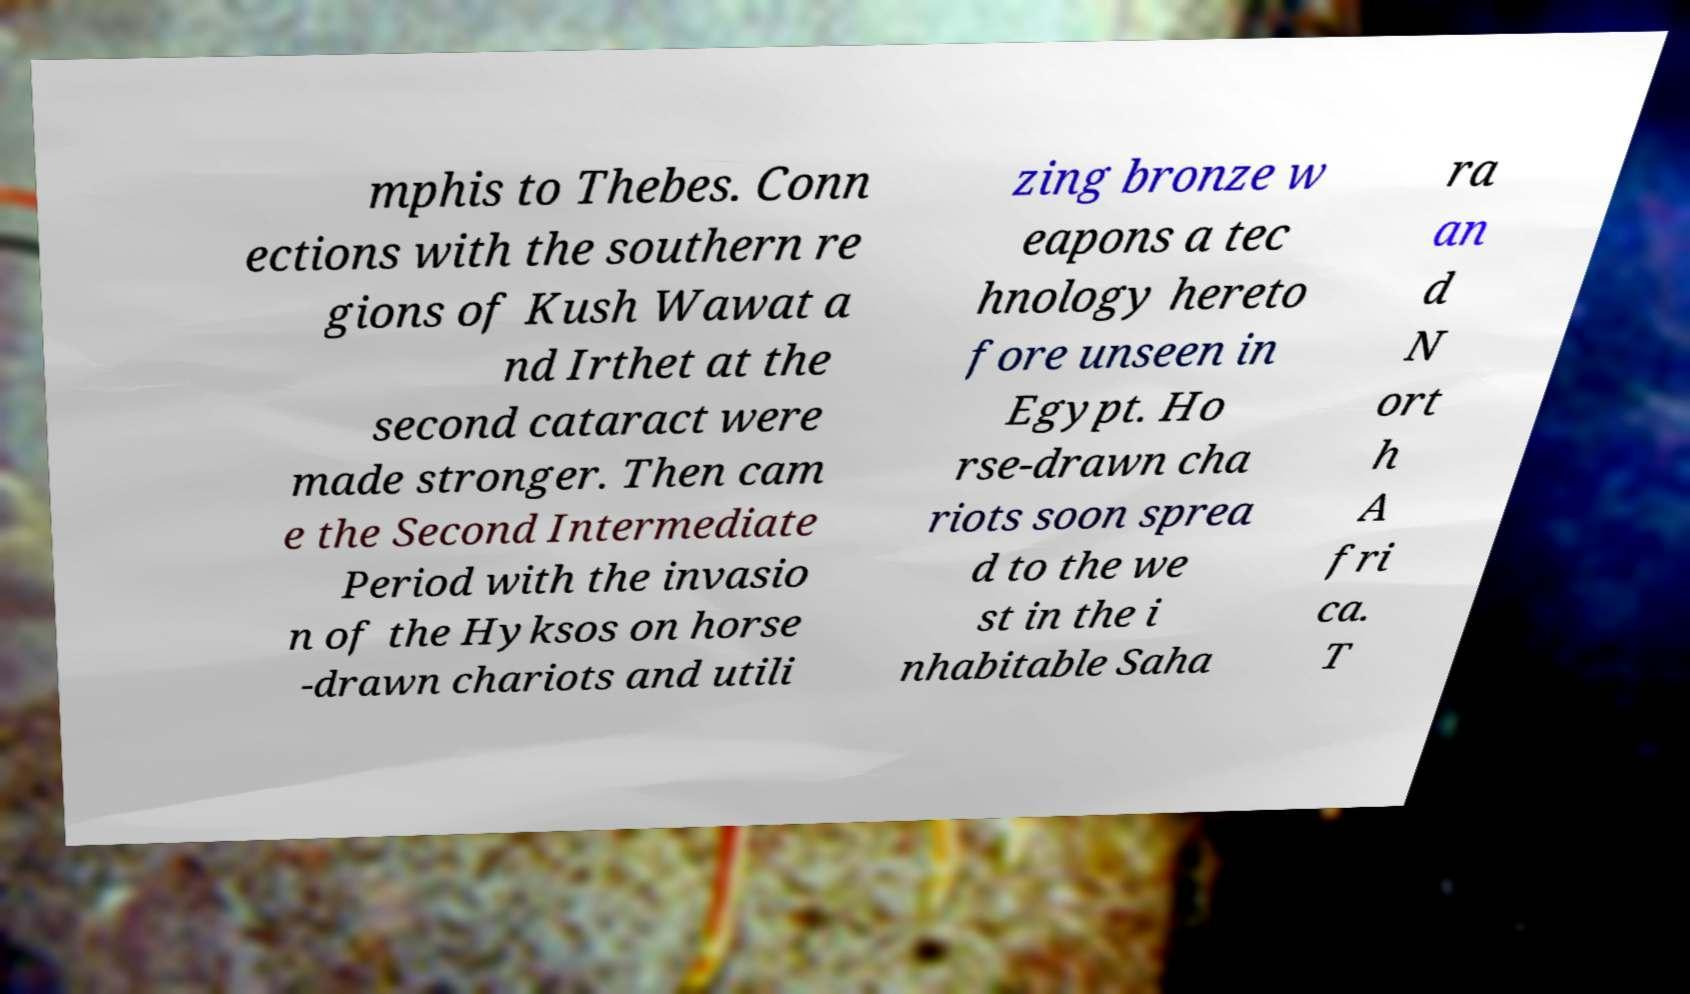Can you accurately transcribe the text from the provided image for me? mphis to Thebes. Conn ections with the southern re gions of Kush Wawat a nd Irthet at the second cataract were made stronger. Then cam e the Second Intermediate Period with the invasio n of the Hyksos on horse -drawn chariots and utili zing bronze w eapons a tec hnology hereto fore unseen in Egypt. Ho rse-drawn cha riots soon sprea d to the we st in the i nhabitable Saha ra an d N ort h A fri ca. T 